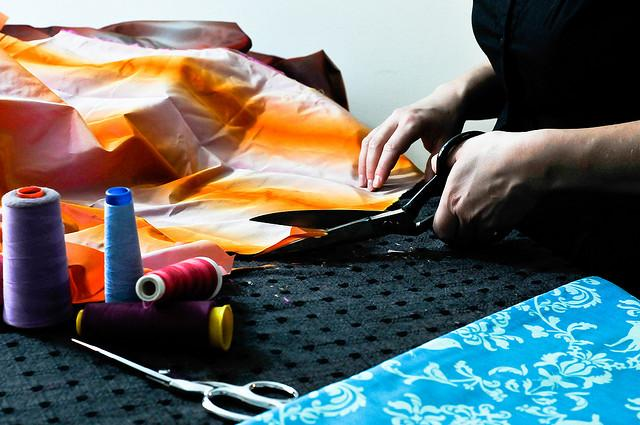What item does the person cut?

Choices:
A) cloth
B) paper
C) markers
D) chalk cloth 